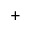Convert formula to latex. <formula><loc_0><loc_0><loc_500><loc_500>^ { + }</formula> 